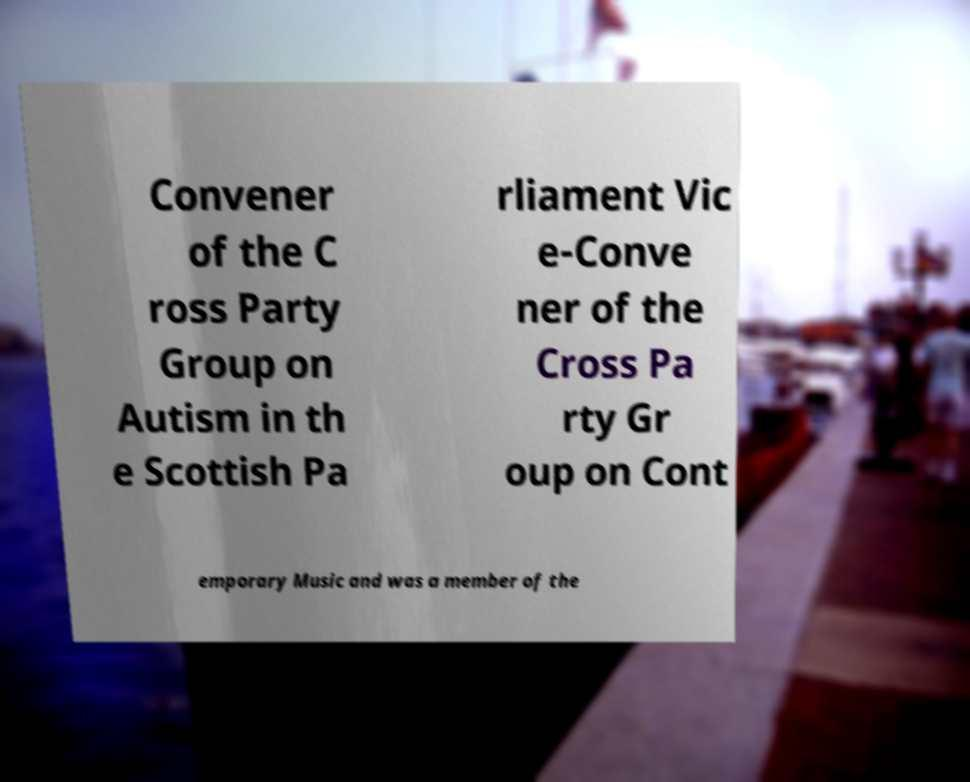Could you assist in decoding the text presented in this image and type it out clearly? Convener of the C ross Party Group on Autism in th e Scottish Pa rliament Vic e-Conve ner of the Cross Pa rty Gr oup on Cont emporary Music and was a member of the 